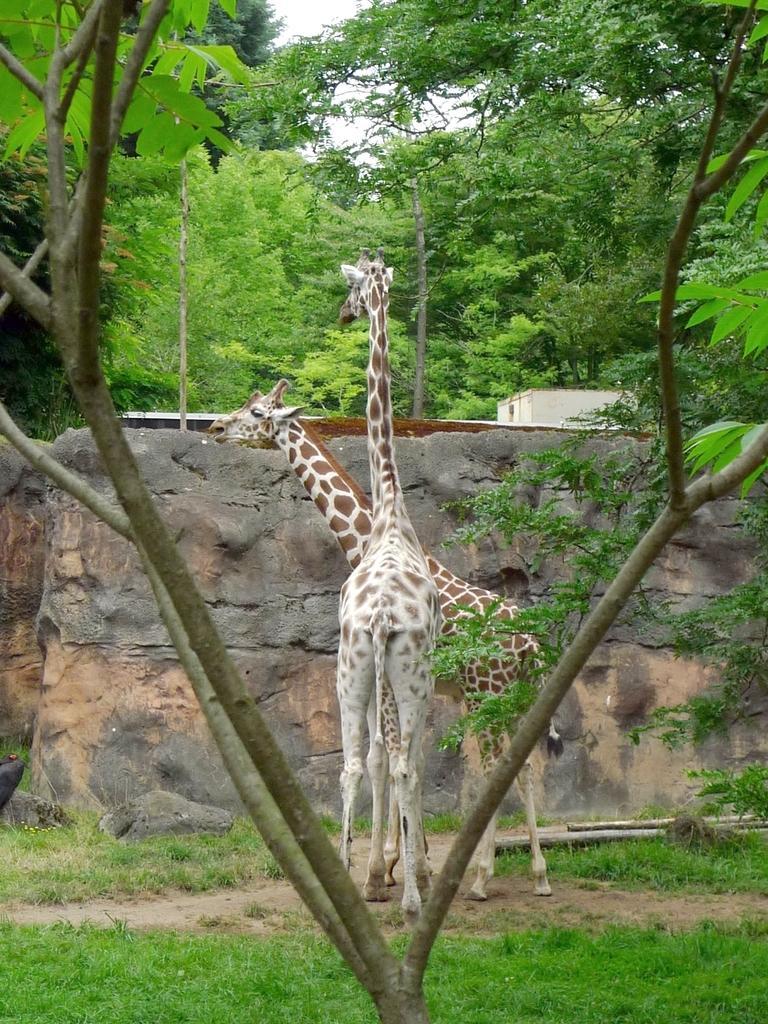Can you describe this image briefly? In this image we can see two giraffes, grass on the ground and some trees, a building in the background and a sky. 